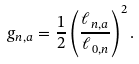Convert formula to latex. <formula><loc_0><loc_0><loc_500><loc_500>g _ { n , a } = \frac { 1 } { 2 } \left ( \frac { \ell _ { n , a } } { \ell _ { 0 , n } } \right ) ^ { 2 } .</formula> 